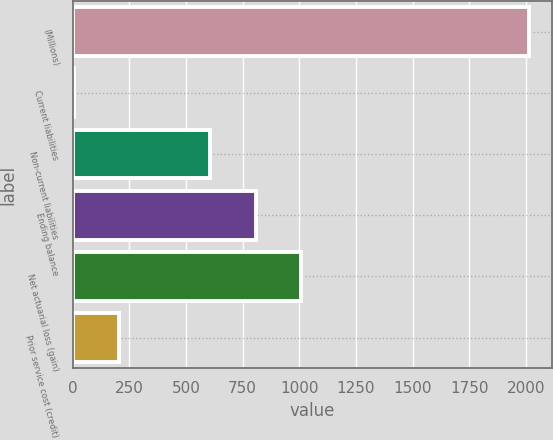Convert chart. <chart><loc_0><loc_0><loc_500><loc_500><bar_chart><fcel>(Millions)<fcel>Current liabilities<fcel>Non-current liabilities<fcel>Ending balance<fcel>Net actuarial loss (gain)<fcel>Prior service cost (credit)<nl><fcel>2013<fcel>4<fcel>608<fcel>808.9<fcel>1009.8<fcel>204.9<nl></chart> 